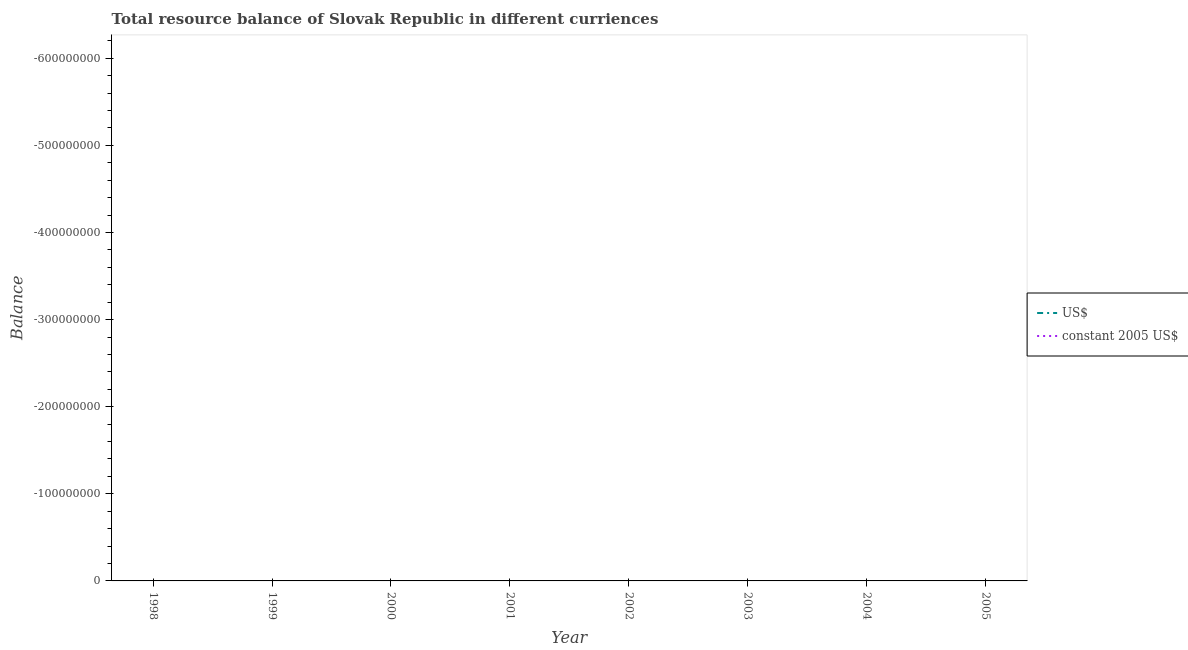How many different coloured lines are there?
Ensure brevity in your answer.  0. Is the number of lines equal to the number of legend labels?
Keep it short and to the point. No. What is the resource balance in us$ in 2003?
Provide a succinct answer. 0. What is the difference between the resource balance in constant us$ in 2005 and the resource balance in us$ in 2004?
Ensure brevity in your answer.  0. Is the resource balance in us$ strictly greater than the resource balance in constant us$ over the years?
Your response must be concise. No. How many years are there in the graph?
Offer a terse response. 8. Are the values on the major ticks of Y-axis written in scientific E-notation?
Your response must be concise. No. How many legend labels are there?
Make the answer very short. 2. What is the title of the graph?
Ensure brevity in your answer.  Total resource balance of Slovak Republic in different curriences. What is the label or title of the Y-axis?
Your response must be concise. Balance. What is the Balance of US$ in 1998?
Keep it short and to the point. 0. What is the Balance in constant 2005 US$ in 1999?
Ensure brevity in your answer.  0. What is the Balance of US$ in 2001?
Provide a short and direct response. 0. What is the Balance of constant 2005 US$ in 2001?
Provide a succinct answer. 0. What is the Balance of US$ in 2002?
Make the answer very short. 0. What is the Balance of US$ in 2003?
Offer a very short reply. 0. What is the Balance in US$ in 2004?
Offer a very short reply. 0. What is the Balance in constant 2005 US$ in 2004?
Your answer should be very brief. 0. What is the total Balance in constant 2005 US$ in the graph?
Offer a terse response. 0. What is the average Balance of US$ per year?
Keep it short and to the point. 0. 